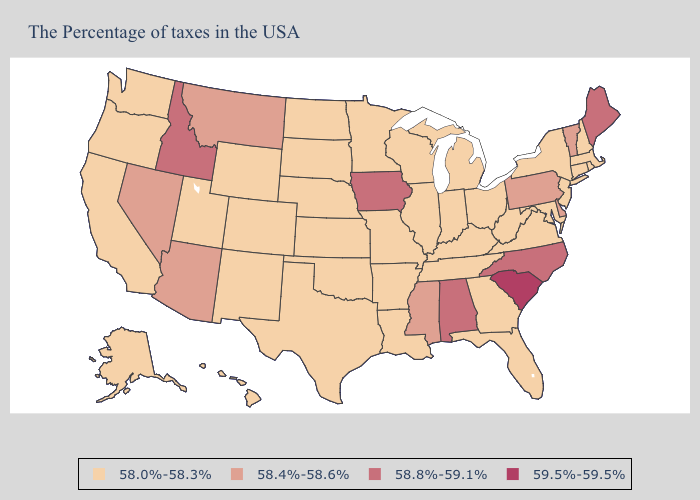What is the value of Mississippi?
Concise answer only. 58.4%-58.6%. Name the states that have a value in the range 58.4%-58.6%?
Quick response, please. Vermont, Delaware, Pennsylvania, Mississippi, Montana, Arizona, Nevada. Does Washington have the highest value in the West?
Give a very brief answer. No. Does South Dakota have the highest value in the USA?
Answer briefly. No. Among the states that border Montana , which have the lowest value?
Answer briefly. South Dakota, North Dakota, Wyoming. Does Arizona have the highest value in the USA?
Quick response, please. No. Among the states that border Oklahoma , which have the highest value?
Concise answer only. Missouri, Arkansas, Kansas, Texas, Colorado, New Mexico. Among the states that border Iowa , which have the lowest value?
Give a very brief answer. Wisconsin, Illinois, Missouri, Minnesota, Nebraska, South Dakota. Name the states that have a value in the range 58.8%-59.1%?
Concise answer only. Maine, North Carolina, Alabama, Iowa, Idaho. What is the value of Kansas?
Give a very brief answer. 58.0%-58.3%. What is the value of Georgia?
Be succinct. 58.0%-58.3%. Is the legend a continuous bar?
Give a very brief answer. No. Among the states that border New Mexico , which have the lowest value?
Quick response, please. Oklahoma, Texas, Colorado, Utah. What is the value of Texas?
Be succinct. 58.0%-58.3%. What is the value of Tennessee?
Give a very brief answer. 58.0%-58.3%. 